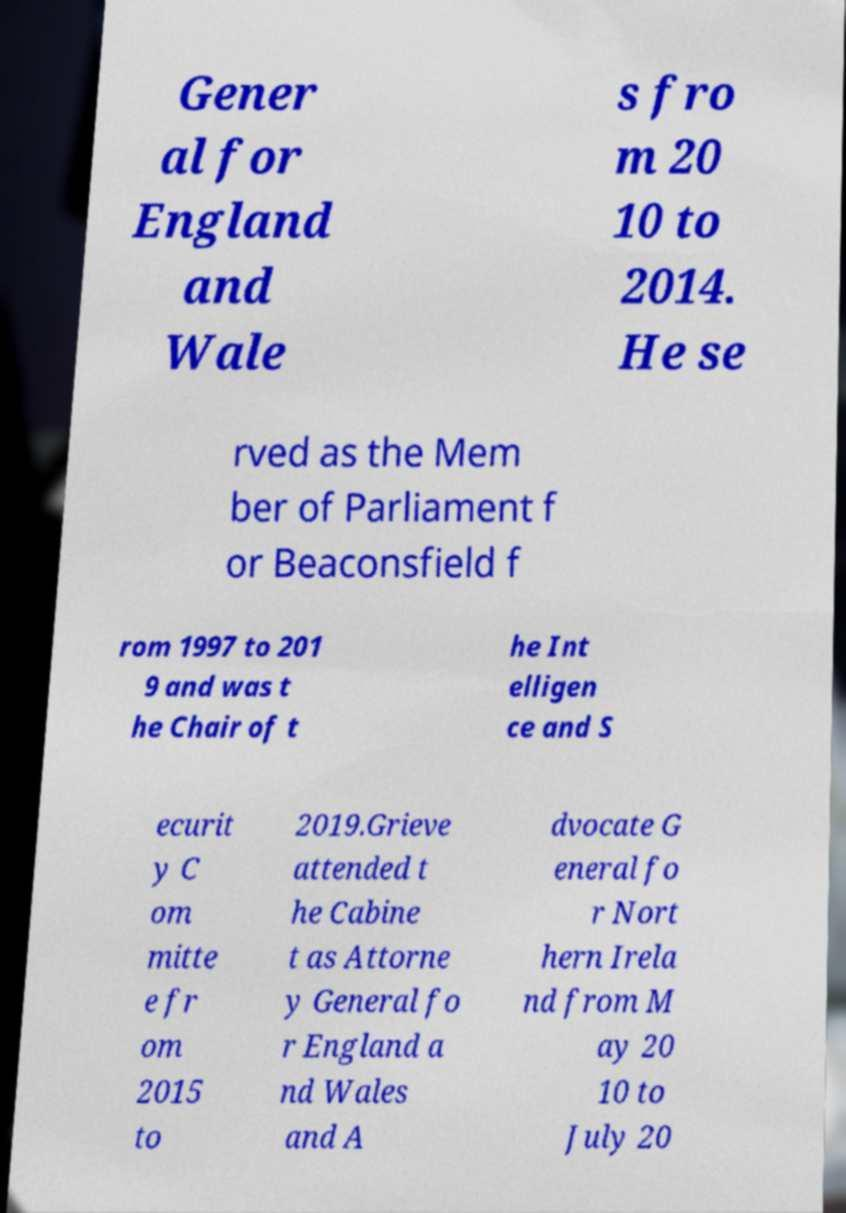Could you assist in decoding the text presented in this image and type it out clearly? Gener al for England and Wale s fro m 20 10 to 2014. He se rved as the Mem ber of Parliament f or Beaconsfield f rom 1997 to 201 9 and was t he Chair of t he Int elligen ce and S ecurit y C om mitte e fr om 2015 to 2019.Grieve attended t he Cabine t as Attorne y General fo r England a nd Wales and A dvocate G eneral fo r Nort hern Irela nd from M ay 20 10 to July 20 